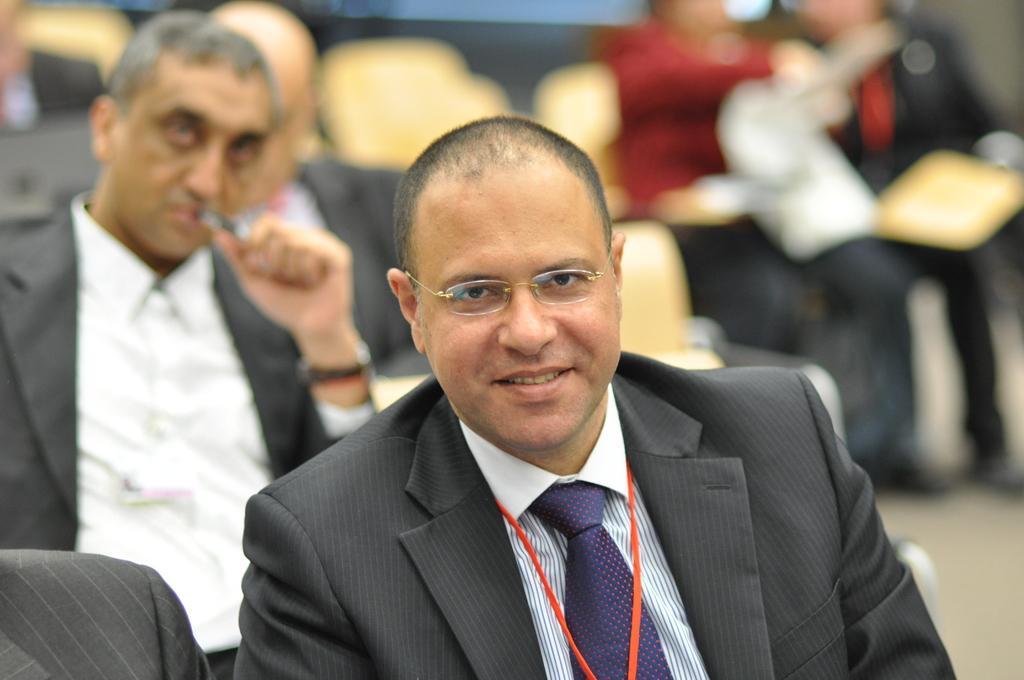Please provide a concise description of this image. In this image I can see few people sitting on chairs. In front one person is wearing black and white dress and purple tie. Background is blurred. 